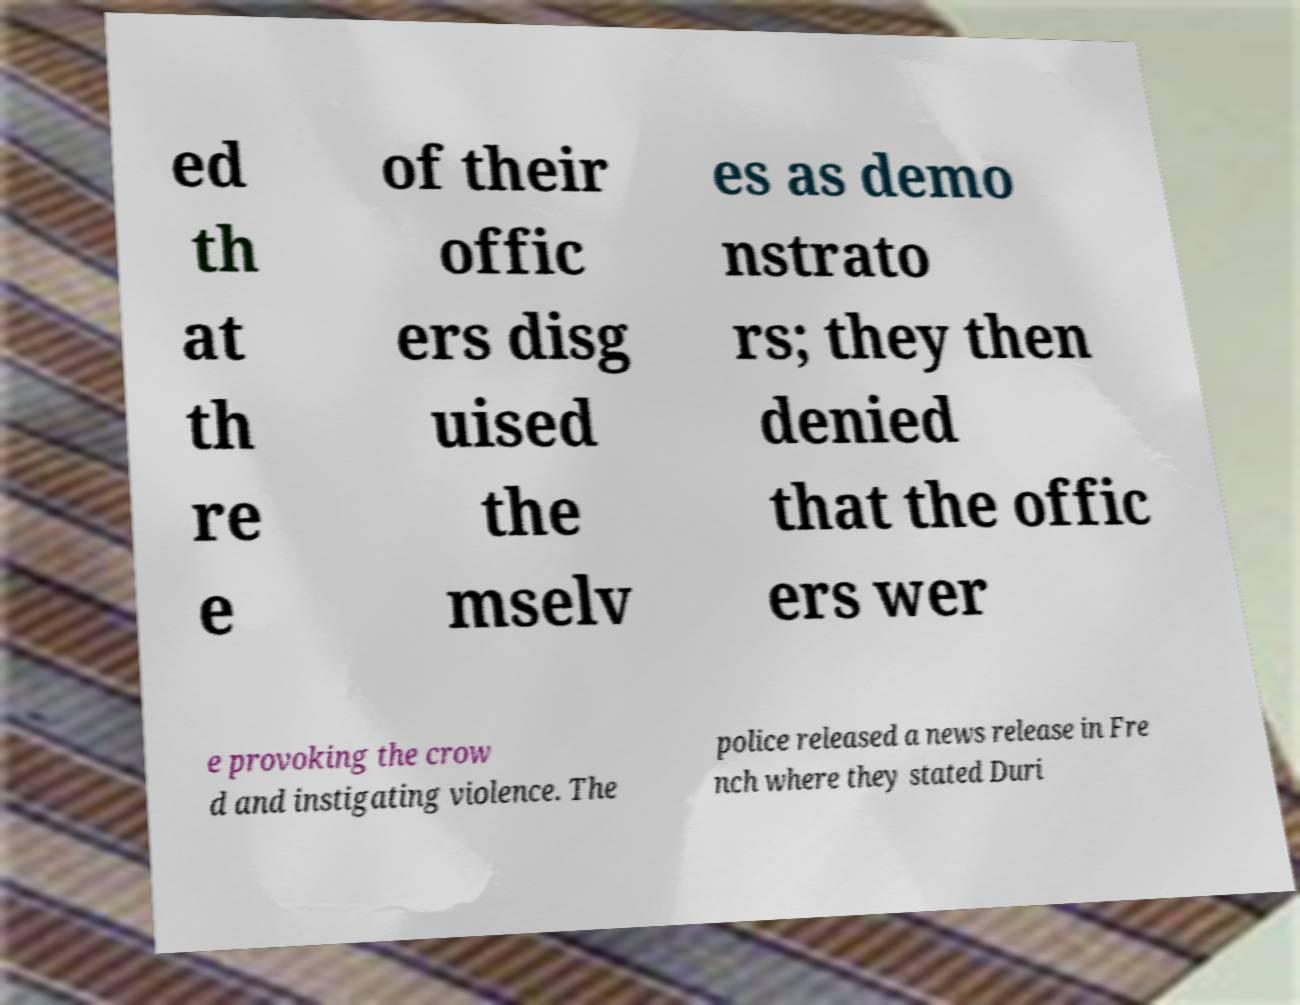There's text embedded in this image that I need extracted. Can you transcribe it verbatim? ed th at th re e of their offic ers disg uised the mselv es as demo nstrato rs; they then denied that the offic ers wer e provoking the crow d and instigating violence. The police released a news release in Fre nch where they stated Duri 